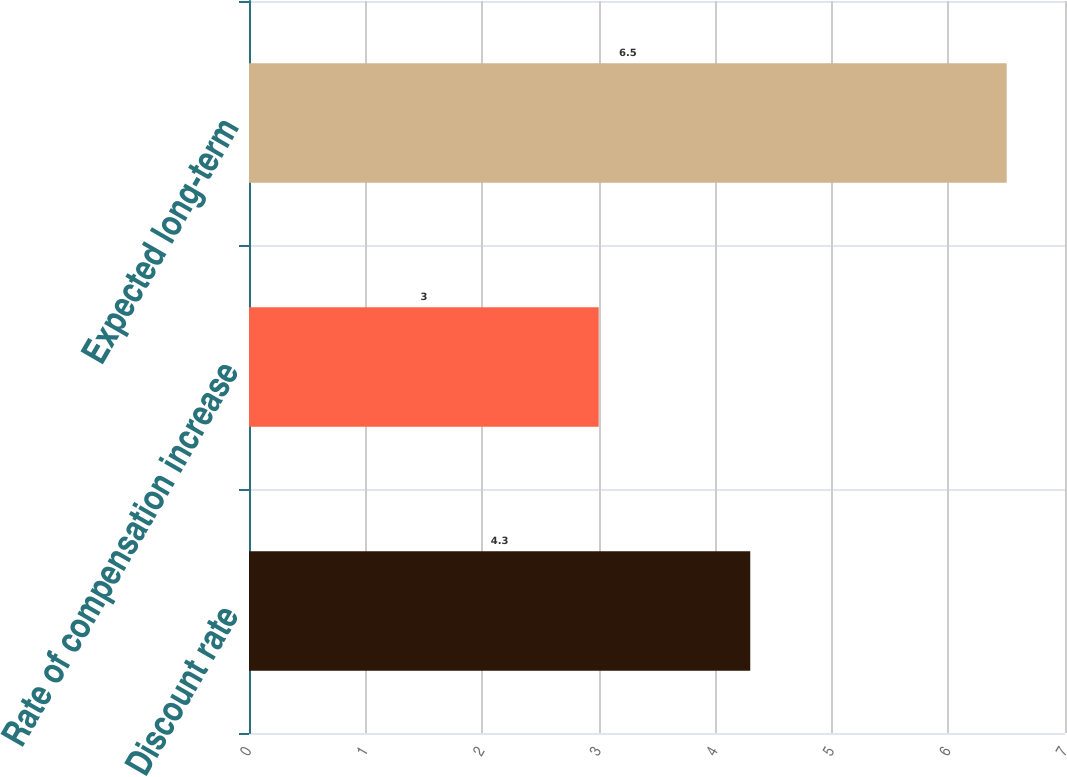<chart> <loc_0><loc_0><loc_500><loc_500><bar_chart><fcel>Discount rate<fcel>Rate of compensation increase<fcel>Expected long-term<nl><fcel>4.3<fcel>3<fcel>6.5<nl></chart> 